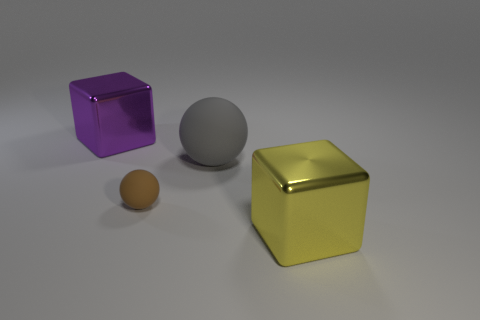Add 2 yellow shiny cubes. How many objects exist? 6 Subtract all yellow shiny blocks. Subtract all big red metallic cubes. How many objects are left? 3 Add 1 gray balls. How many gray balls are left? 2 Add 1 tiny brown metal cubes. How many tiny brown metal cubes exist? 1 Subtract 0 gray cylinders. How many objects are left? 4 